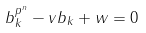Convert formula to latex. <formula><loc_0><loc_0><loc_500><loc_500>b _ { k } ^ { p ^ { n } } - v b _ { k } + w = 0</formula> 